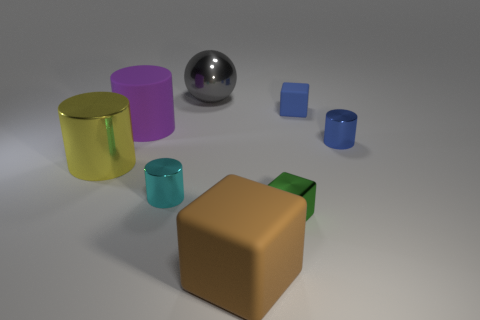Subtract all metallic cylinders. How many cylinders are left? 1 Add 2 brown rubber objects. How many objects exist? 10 Subtract all blue cylinders. How many cylinders are left? 3 Subtract all cubes. How many objects are left? 5 Subtract all green cylinders. Subtract all brown spheres. How many cylinders are left? 4 Subtract all small purple metal things. Subtract all shiny cubes. How many objects are left? 7 Add 8 large shiny things. How many large shiny things are left? 10 Add 6 yellow shiny objects. How many yellow shiny objects exist? 7 Subtract 1 green cubes. How many objects are left? 7 